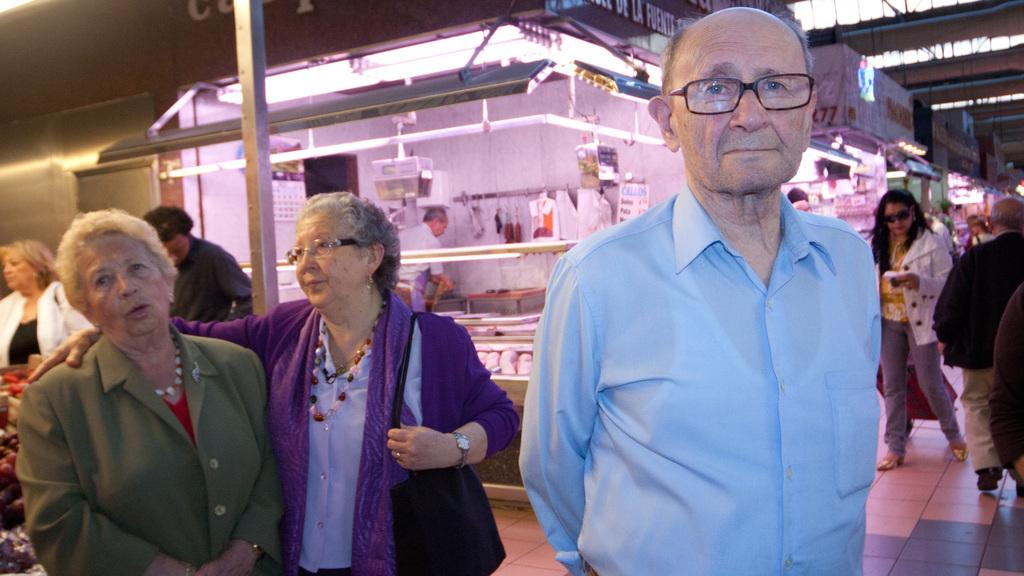What are the people in the image doing? There are many persons walking on the ground in the image. What can be seen in the background of the image? There are stories and persons visible in the background of the image. What objects are present at the top of the image? Name boards and lights are visible at the top of the image. Can you see an owl biting a door in the image? No, there is no owl or door present in the image. 